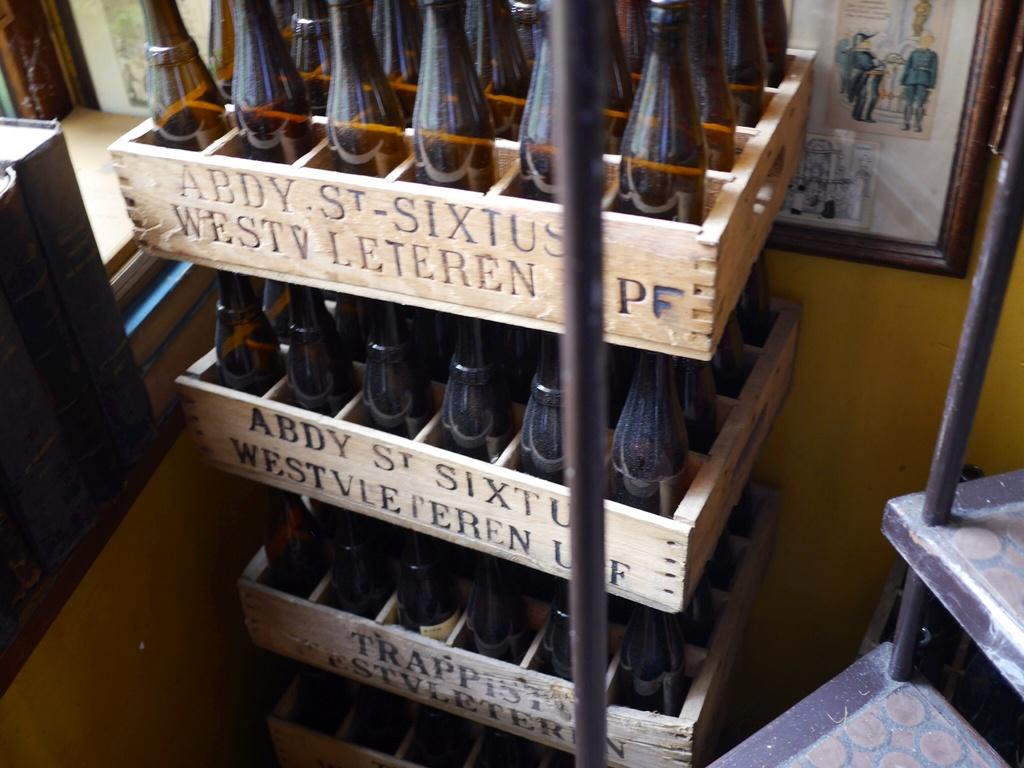What are the first four letters on the upper case?
Offer a very short reply. Abdy. What is the brand on the bottle case?
Give a very brief answer. Abdy st sixtus. 